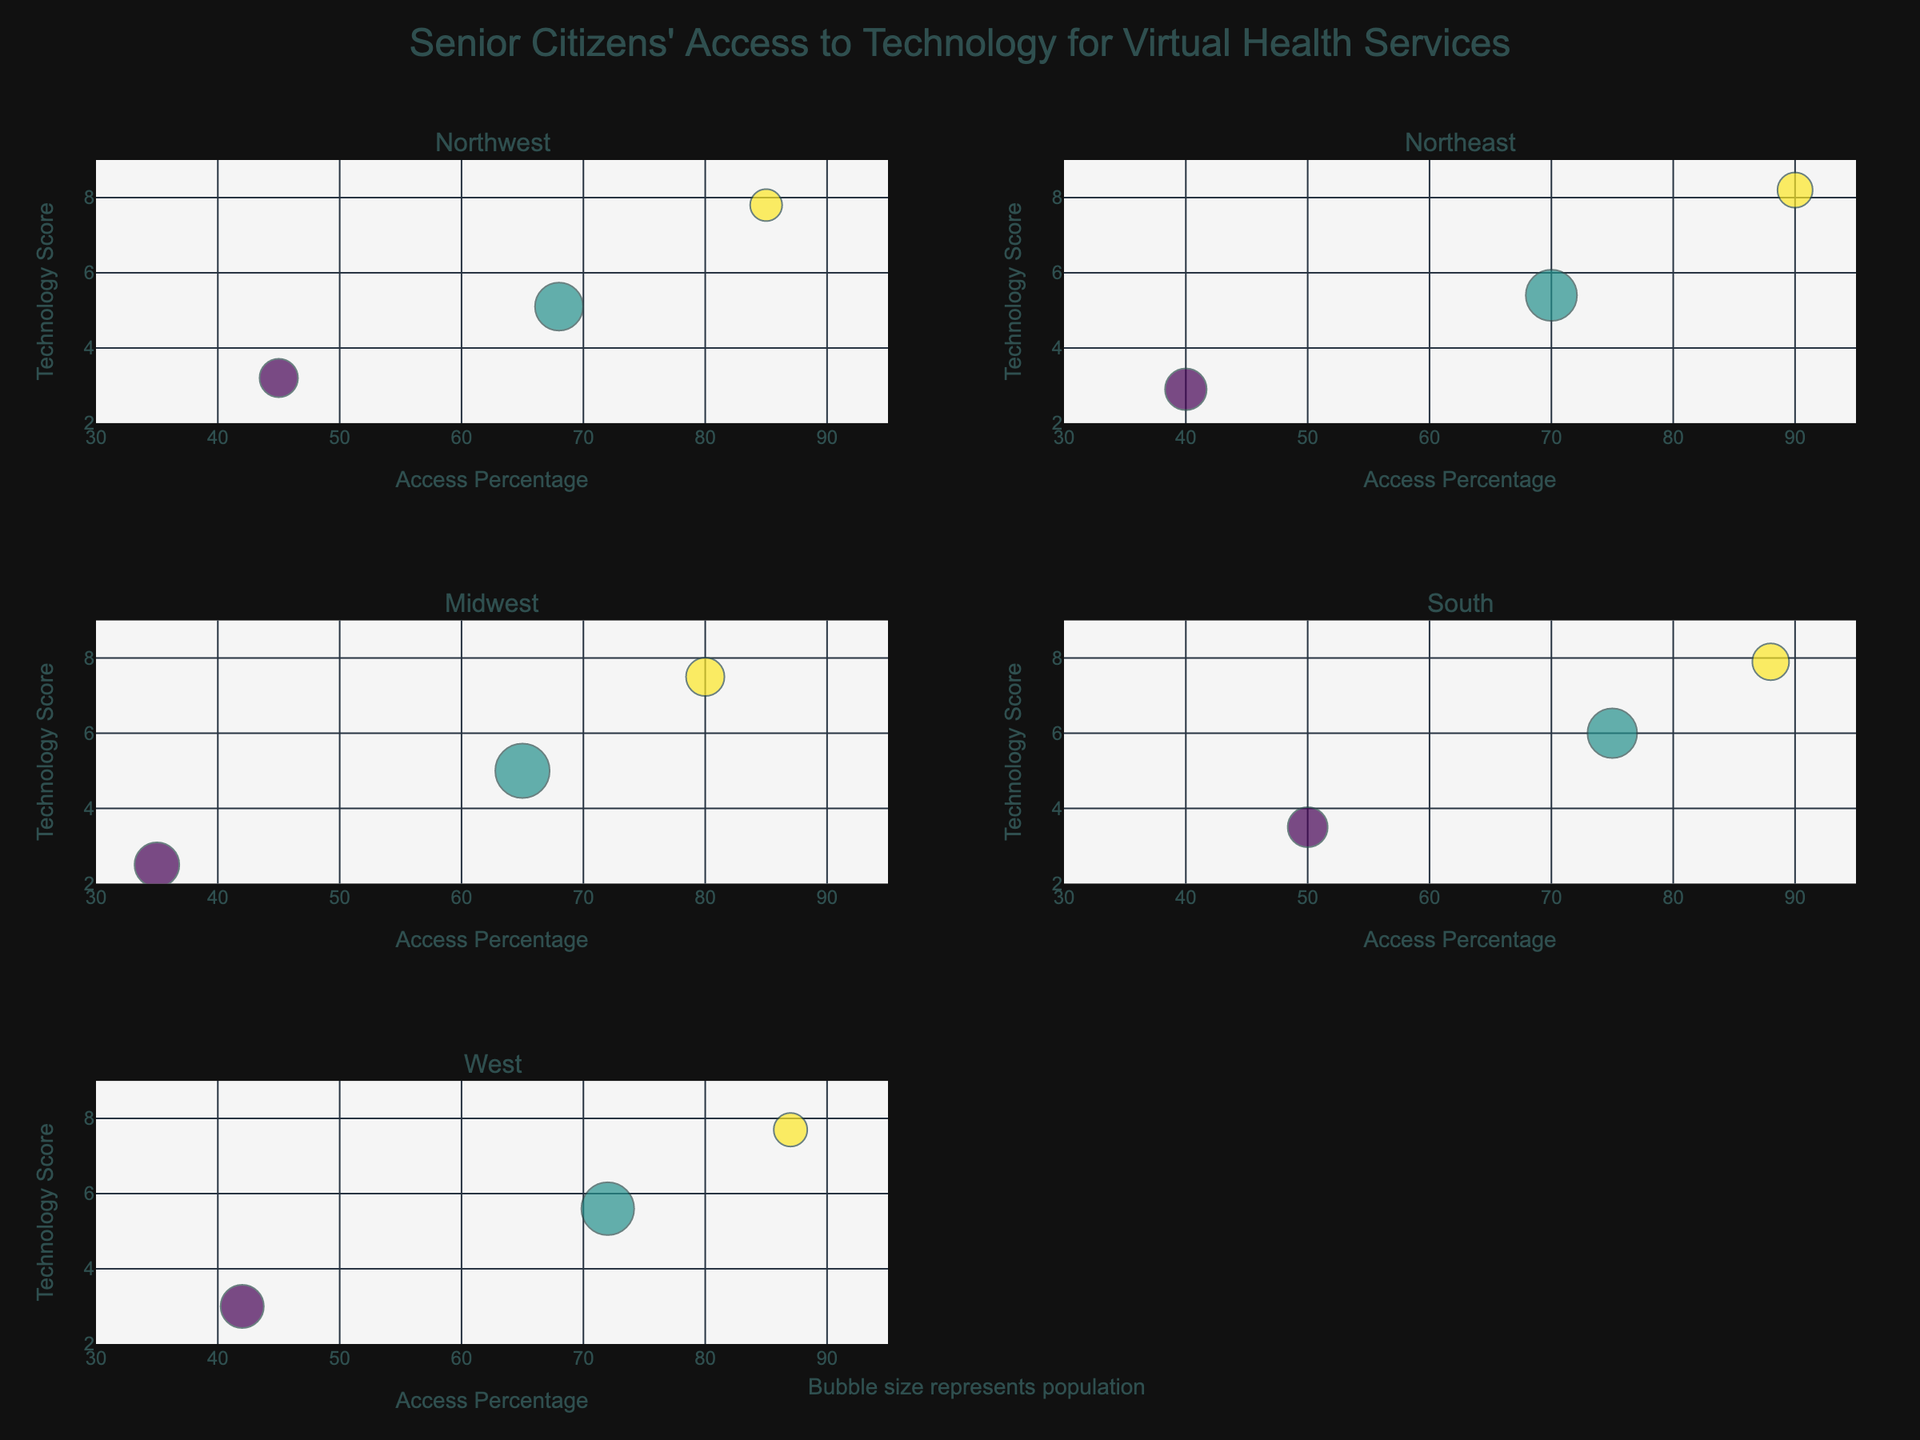What is the general title of the figure? The title is displayed at the top of the figure and summarizes the overall topic being visualized.
Answer: Senior Citizens' Access to Technology for Virtual Health Services Which region has the highest technology score for seniors with high socioeconomic status? By examining the y-axis for each subplot, identify the highest point for 'High' socioeconomic status and note the corresponding region.
Answer: Northeast How large is the bubble representing the senior population with medium socioeconomic status in the Midwest? Locate the Midwest subplot and find the bubble corresponding to medium socioeconomic status. Population size is proportional to bubble size and can be estimated.
Answer: Around 34 (since the population is 17,000 / 500) What is the access percentage difference between seniors with low and high socioeconomic statuses in the South? Identify the x-axis values for low and high socioeconomic statuses in the South subplot, then subtract the lower value from the higher value.
Answer: 38% (88% - 50%) Which region shows the least access to technology for seniors with low socioeconomic status? Compare the x-axis values for low socioeconomic status across all subplots.
Answer: Midwest What is the average technology score for seniors with medium socioeconomic status across all regions? Find the y-values for medium socioeconomic status in each subplot and calculate their average: (5.1 + 5.4 + 5.0 + 6.0 + 5.6) / 5 = 5.42.
Answer: 5.42 In which region do seniors with high socioeconomic status have a higher access percentage than in the Northwest? Compare the x-axis values for high socioeconomic status between Northwest and other regions, determine which are higher.
Answer: Northeast, South, West Does any region show a higher technology score for medium socioeconomic status compared to the Northwest’s high socioeconomic status? Compare the y-values of medium socioeconomic status across regions with the y-value of high socioeconomic status in the Northwest subplot.
Answer: No Which region displays the highest population for seniors with low socioeconomic status as indicated by bubble size? Examine the subplot for each region, compare the bubble sizes for low socioeconomic status, and identify the largest bubble.
Answer: Midwest 